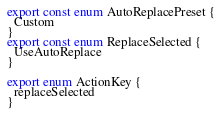Convert code to text. <code><loc_0><loc_0><loc_500><loc_500><_TypeScript_>export const enum AutoReplacePreset {
  Custom
}
export const enum ReplaceSelected {
  UseAutoReplace
}

export enum ActionKey {
  replaceSelected
}
</code> 